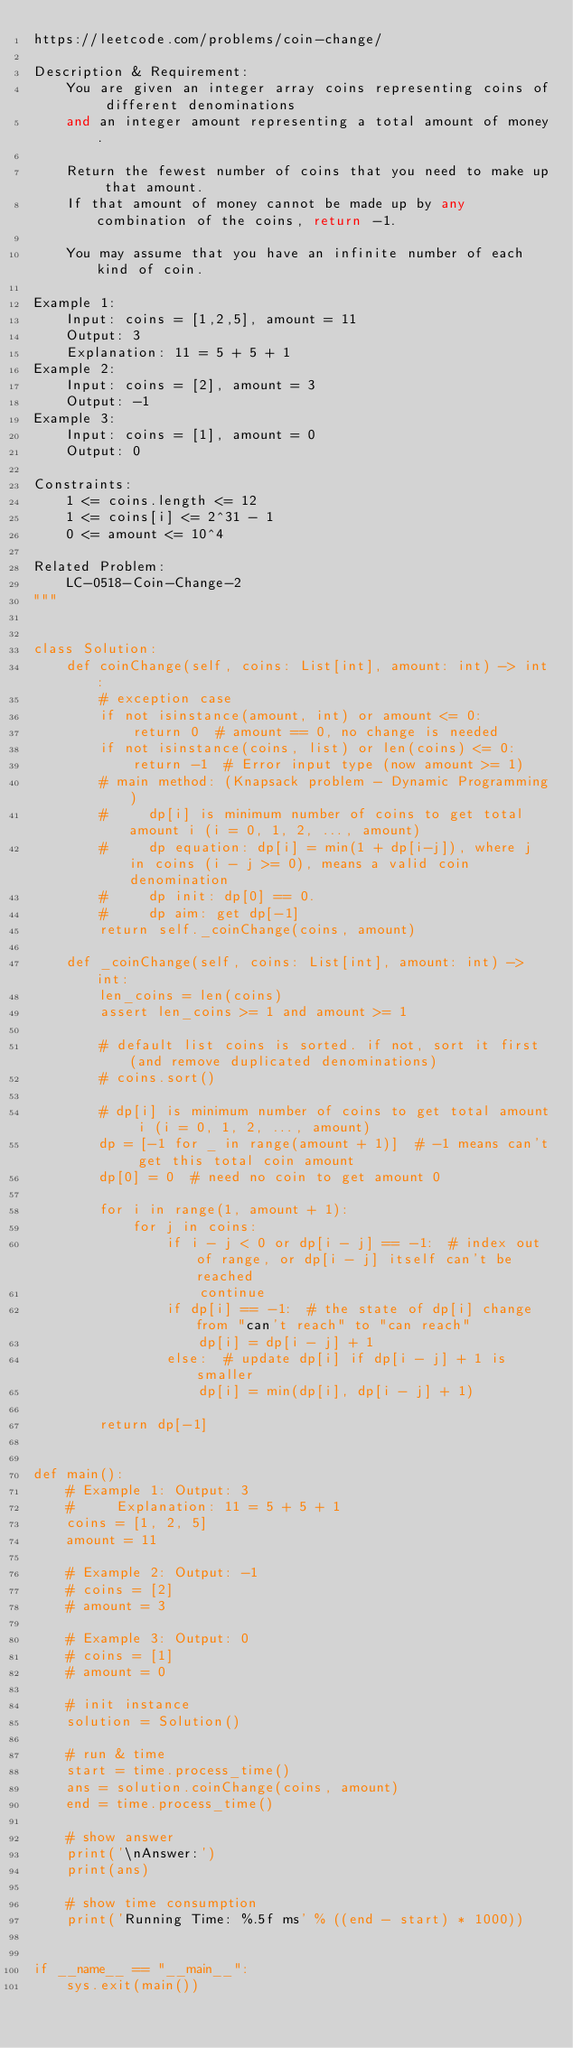Convert code to text. <code><loc_0><loc_0><loc_500><loc_500><_Python_>https://leetcode.com/problems/coin-change/

Description & Requirement:
    You are given an integer array coins representing coins of different denominations 
    and an integer amount representing a total amount of money.

    Return the fewest number of coins that you need to make up that amount. 
    If that amount of money cannot be made up by any combination of the coins, return -1.

    You may assume that you have an infinite number of each kind of coin.

Example 1:
    Input: coins = [1,2,5], amount = 11
    Output: 3
    Explanation: 11 = 5 + 5 + 1
Example 2:
    Input: coins = [2], amount = 3
    Output: -1
Example 3:
    Input: coins = [1], amount = 0
    Output: 0

Constraints:
    1 <= coins.length <= 12
    1 <= coins[i] <= 2^31 - 1
    0 <= amount <= 10^4

Related Problem:
    LC-0518-Coin-Change-2
"""


class Solution:
    def coinChange(self, coins: List[int], amount: int) -> int:
        # exception case
        if not isinstance(amount, int) or amount <= 0:
            return 0  # amount == 0, no change is needed
        if not isinstance(coins, list) or len(coins) <= 0:
            return -1  # Error input type (now amount >= 1)
        # main method: (Knapsack problem - Dynamic Programming)
        #     dp[i] is minimum number of coins to get total amount i (i = 0, 1, 2, ..., amount)
        #     dp equation: dp[i] = min(1 + dp[i-j]), where j in coins (i - j >= 0), means a valid coin denomination
        #     dp init: dp[0] == 0.
        #     dp aim: get dp[-1]
        return self._coinChange(coins, amount)

    def _coinChange(self, coins: List[int], amount: int) -> int:
        len_coins = len(coins)
        assert len_coins >= 1 and amount >= 1

        # default list coins is sorted. if not, sort it first (and remove duplicated denominations)
        # coins.sort()

        # dp[i] is minimum number of coins to get total amount i (i = 0, 1, 2, ..., amount)
        dp = [-1 for _ in range(amount + 1)]  # -1 means can't get this total coin amount
        dp[0] = 0  # need no coin to get amount 0

        for i in range(1, amount + 1):
            for j in coins:
                if i - j < 0 or dp[i - j] == -1:  # index out of range, or dp[i - j] itself can't be reached
                    continue
                if dp[i] == -1:  # the state of dp[i] change from "can't reach" to "can reach"
                    dp[i] = dp[i - j] + 1
                else:  # update dp[i] if dp[i - j] + 1 is smaller
                    dp[i] = min(dp[i], dp[i - j] + 1)

        return dp[-1]


def main():
    # Example 1: Output: 3
    #     Explanation: 11 = 5 + 5 + 1
    coins = [1, 2, 5]
    amount = 11

    # Example 2: Output: -1
    # coins = [2]
    # amount = 3

    # Example 3: Output: 0
    # coins = [1]
    # amount = 0

    # init instance
    solution = Solution()

    # run & time
    start = time.process_time()
    ans = solution.coinChange(coins, amount)
    end = time.process_time()

    # show answer
    print('\nAnswer:')
    print(ans)

    # show time consumption
    print('Running Time: %.5f ms' % ((end - start) * 1000))


if __name__ == "__main__":
    sys.exit(main())
</code> 